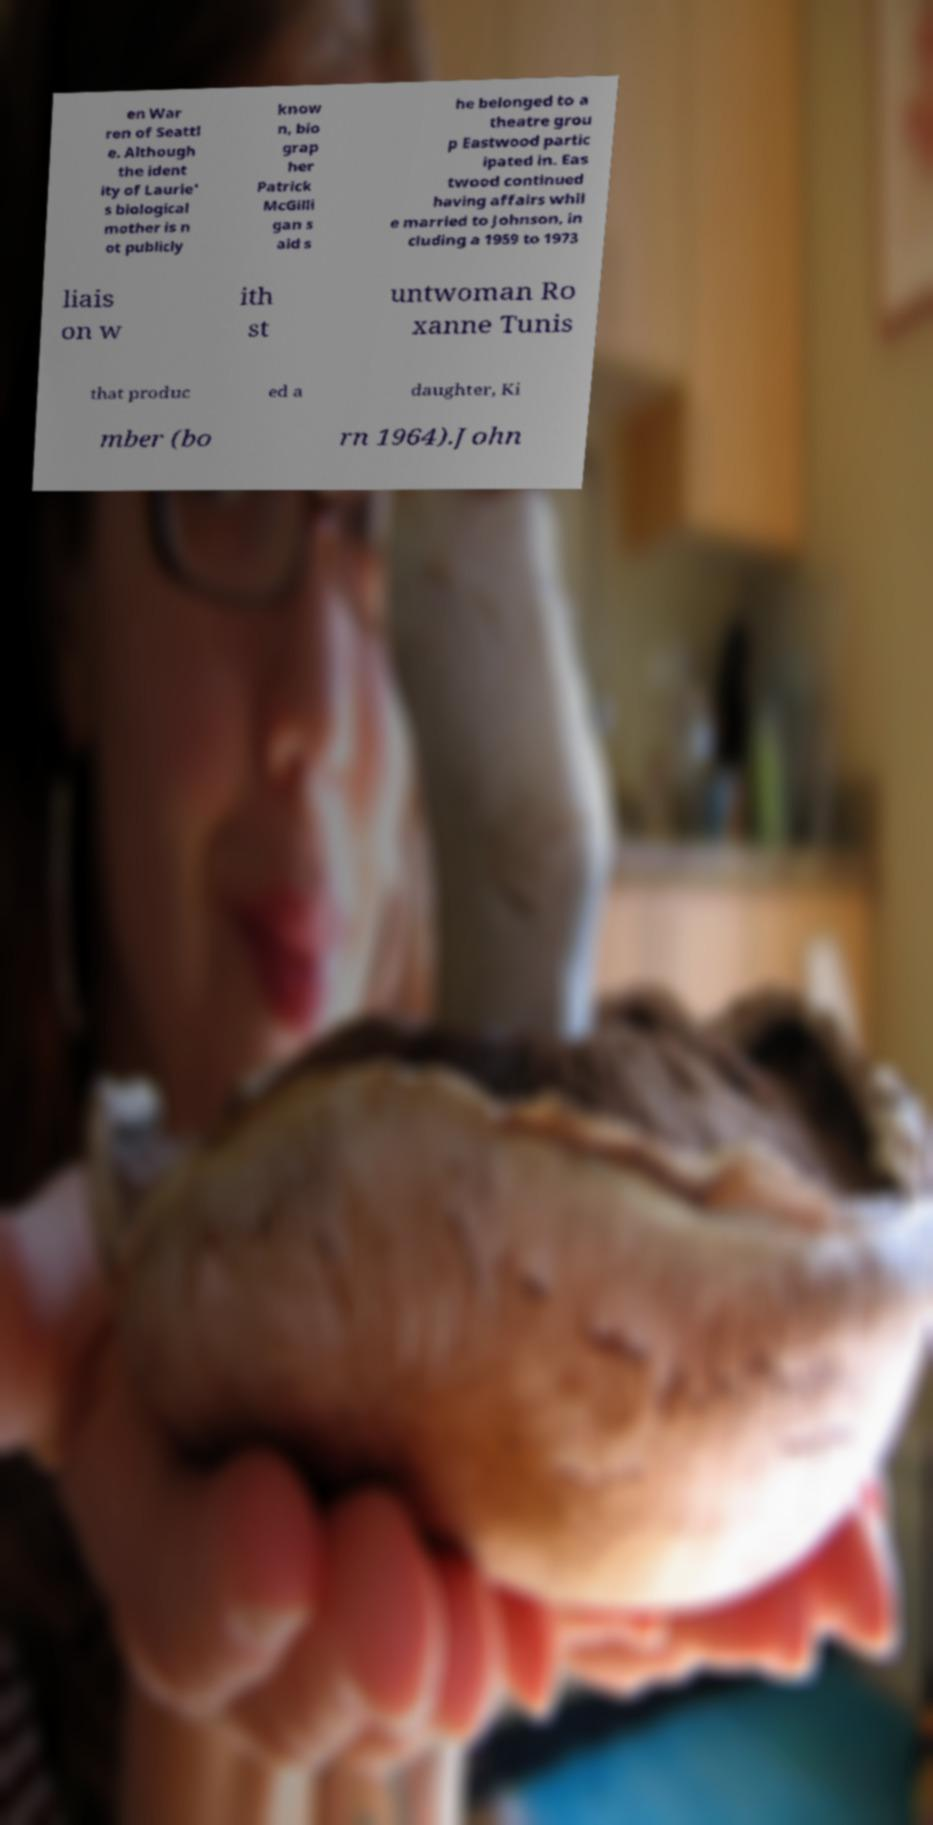Could you extract and type out the text from this image? en War ren of Seattl e. Although the ident ity of Laurie' s biological mother is n ot publicly know n, bio grap her Patrick McGilli gan s aid s he belonged to a theatre grou p Eastwood partic ipated in. Eas twood continued having affairs whil e married to Johnson, in cluding a 1959 to 1973 liais on w ith st untwoman Ro xanne Tunis that produc ed a daughter, Ki mber (bo rn 1964).John 